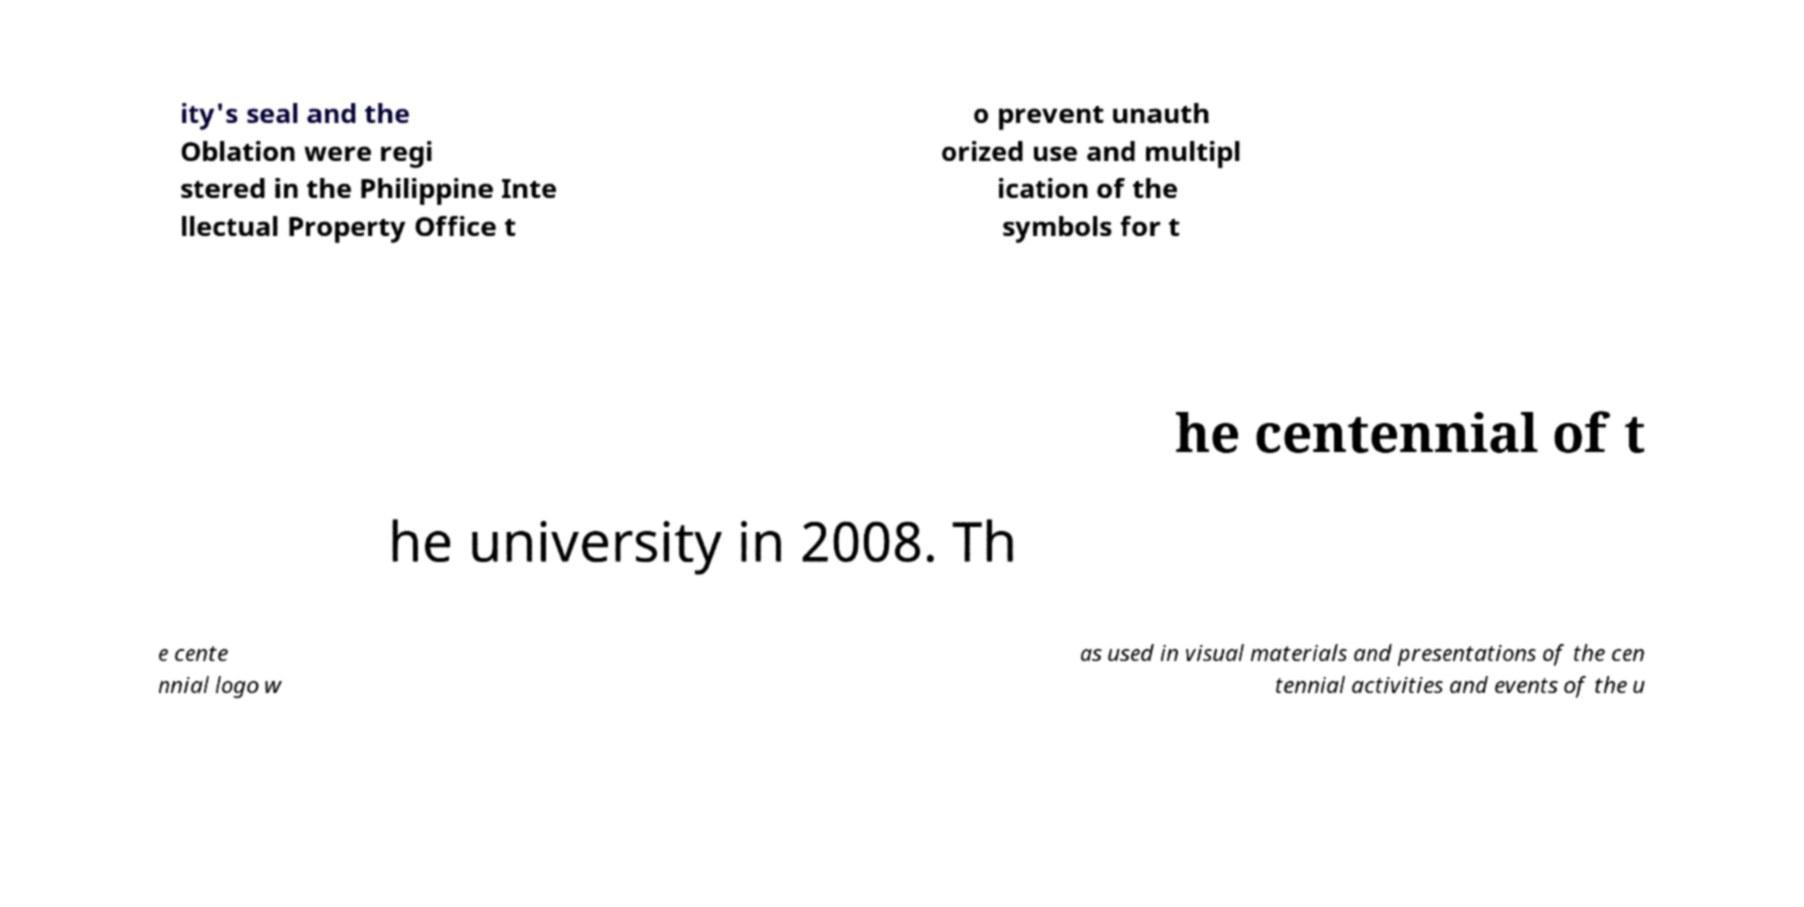There's text embedded in this image that I need extracted. Can you transcribe it verbatim? ity's seal and the Oblation were regi stered in the Philippine Inte llectual Property Office t o prevent unauth orized use and multipl ication of the symbols for t he centennial of t he university in 2008. Th e cente nnial logo w as used in visual materials and presentations of the cen tennial activities and events of the u 